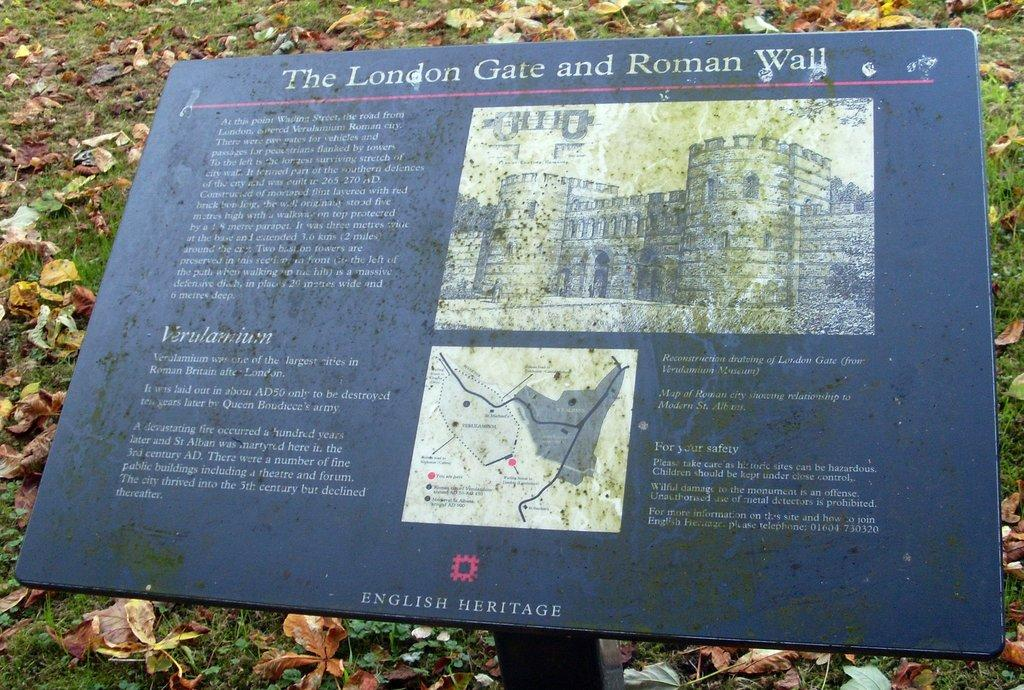What is the main object in the image? There is a board on a pole in the image. What type of environment is depicted in the image? The image shows grass, which suggests a natural setting. Are there any other natural elements visible in the image? Yes, leaves are present in the image. Where is the shop located in the image? There is no shop present in the image. What story is being told by the board on the pole? The board on the pole does not tell a story; it is simply an object in the image. 